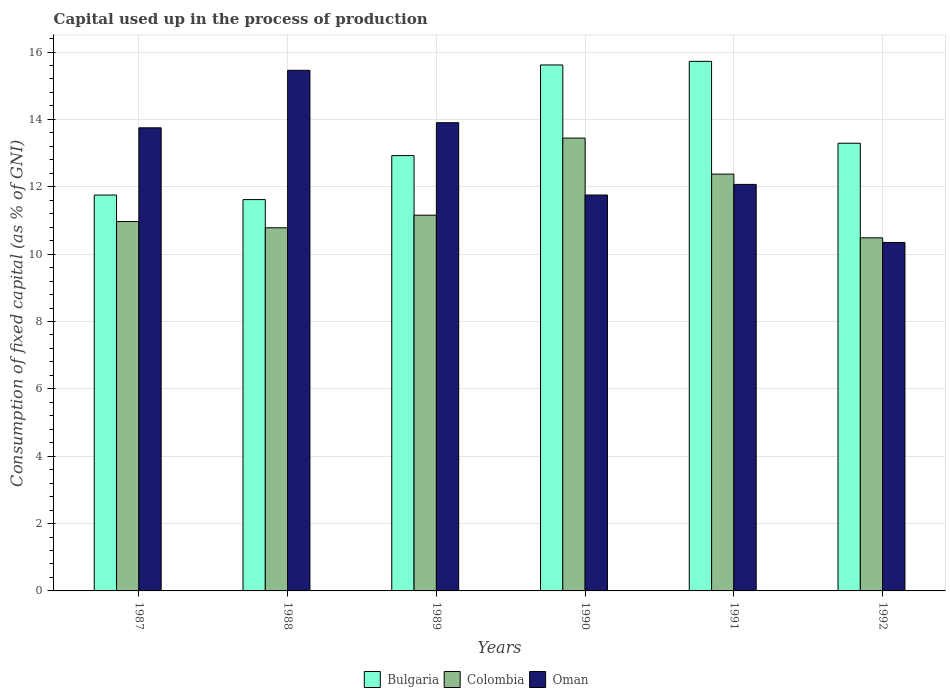How many groups of bars are there?
Ensure brevity in your answer.  6. Are the number of bars per tick equal to the number of legend labels?
Keep it short and to the point. Yes. How many bars are there on the 1st tick from the left?
Offer a terse response. 3. How many bars are there on the 4th tick from the right?
Provide a succinct answer. 3. What is the label of the 3rd group of bars from the left?
Ensure brevity in your answer.  1989. In how many cases, is the number of bars for a given year not equal to the number of legend labels?
Your answer should be compact. 0. What is the capital used up in the process of production in Oman in 1990?
Make the answer very short. 11.76. Across all years, what is the maximum capital used up in the process of production in Bulgaria?
Your answer should be very brief. 15.72. Across all years, what is the minimum capital used up in the process of production in Colombia?
Your answer should be compact. 10.48. In which year was the capital used up in the process of production in Oman minimum?
Provide a succinct answer. 1992. What is the total capital used up in the process of production in Colombia in the graph?
Make the answer very short. 69.21. What is the difference between the capital used up in the process of production in Bulgaria in 1988 and that in 1989?
Make the answer very short. -1.31. What is the difference between the capital used up in the process of production in Bulgaria in 1987 and the capital used up in the process of production in Colombia in 1991?
Ensure brevity in your answer.  -0.62. What is the average capital used up in the process of production in Oman per year?
Your answer should be very brief. 12.88. In the year 1990, what is the difference between the capital used up in the process of production in Colombia and capital used up in the process of production in Bulgaria?
Provide a succinct answer. -2.17. In how many years, is the capital used up in the process of production in Oman greater than 3.2 %?
Ensure brevity in your answer.  6. What is the ratio of the capital used up in the process of production in Oman in 1988 to that in 1990?
Your answer should be compact. 1.31. Is the capital used up in the process of production in Bulgaria in 1987 less than that in 1990?
Offer a terse response. Yes. Is the difference between the capital used up in the process of production in Colombia in 1988 and 1990 greater than the difference between the capital used up in the process of production in Bulgaria in 1988 and 1990?
Give a very brief answer. Yes. What is the difference between the highest and the second highest capital used up in the process of production in Bulgaria?
Offer a very short reply. 0.11. What is the difference between the highest and the lowest capital used up in the process of production in Bulgaria?
Provide a short and direct response. 4.1. In how many years, is the capital used up in the process of production in Bulgaria greater than the average capital used up in the process of production in Bulgaria taken over all years?
Provide a short and direct response. 2. Is the sum of the capital used up in the process of production in Colombia in 1987 and 1988 greater than the maximum capital used up in the process of production in Oman across all years?
Provide a short and direct response. Yes. What does the 1st bar from the right in 1991 represents?
Give a very brief answer. Oman. Are all the bars in the graph horizontal?
Ensure brevity in your answer.  No. How many years are there in the graph?
Your answer should be very brief. 6. What is the difference between two consecutive major ticks on the Y-axis?
Your answer should be very brief. 2. Are the values on the major ticks of Y-axis written in scientific E-notation?
Your response must be concise. No. Does the graph contain any zero values?
Offer a very short reply. No. Where does the legend appear in the graph?
Keep it short and to the point. Bottom center. How many legend labels are there?
Provide a succinct answer. 3. What is the title of the graph?
Your response must be concise. Capital used up in the process of production. What is the label or title of the X-axis?
Your answer should be very brief. Years. What is the label or title of the Y-axis?
Your answer should be compact. Consumption of fixed capital (as % of GNI). What is the Consumption of fixed capital (as % of GNI) of Bulgaria in 1987?
Provide a succinct answer. 11.75. What is the Consumption of fixed capital (as % of GNI) of Colombia in 1987?
Your answer should be very brief. 10.97. What is the Consumption of fixed capital (as % of GNI) in Oman in 1987?
Keep it short and to the point. 13.75. What is the Consumption of fixed capital (as % of GNI) of Bulgaria in 1988?
Give a very brief answer. 11.62. What is the Consumption of fixed capital (as % of GNI) of Colombia in 1988?
Give a very brief answer. 10.78. What is the Consumption of fixed capital (as % of GNI) in Oman in 1988?
Your answer should be very brief. 15.46. What is the Consumption of fixed capital (as % of GNI) of Bulgaria in 1989?
Provide a succinct answer. 12.93. What is the Consumption of fixed capital (as % of GNI) in Colombia in 1989?
Your answer should be compact. 11.16. What is the Consumption of fixed capital (as % of GNI) of Oman in 1989?
Keep it short and to the point. 13.9. What is the Consumption of fixed capital (as % of GNI) in Bulgaria in 1990?
Provide a succinct answer. 15.62. What is the Consumption of fixed capital (as % of GNI) in Colombia in 1990?
Ensure brevity in your answer.  13.45. What is the Consumption of fixed capital (as % of GNI) of Oman in 1990?
Your answer should be very brief. 11.76. What is the Consumption of fixed capital (as % of GNI) of Bulgaria in 1991?
Provide a succinct answer. 15.72. What is the Consumption of fixed capital (as % of GNI) in Colombia in 1991?
Your answer should be compact. 12.38. What is the Consumption of fixed capital (as % of GNI) of Oman in 1991?
Ensure brevity in your answer.  12.07. What is the Consumption of fixed capital (as % of GNI) in Bulgaria in 1992?
Offer a very short reply. 13.29. What is the Consumption of fixed capital (as % of GNI) in Colombia in 1992?
Your answer should be compact. 10.48. What is the Consumption of fixed capital (as % of GNI) of Oman in 1992?
Provide a succinct answer. 10.35. Across all years, what is the maximum Consumption of fixed capital (as % of GNI) of Bulgaria?
Offer a terse response. 15.72. Across all years, what is the maximum Consumption of fixed capital (as % of GNI) in Colombia?
Offer a terse response. 13.45. Across all years, what is the maximum Consumption of fixed capital (as % of GNI) in Oman?
Make the answer very short. 15.46. Across all years, what is the minimum Consumption of fixed capital (as % of GNI) in Bulgaria?
Give a very brief answer. 11.62. Across all years, what is the minimum Consumption of fixed capital (as % of GNI) of Colombia?
Provide a succinct answer. 10.48. Across all years, what is the minimum Consumption of fixed capital (as % of GNI) in Oman?
Your response must be concise. 10.35. What is the total Consumption of fixed capital (as % of GNI) of Bulgaria in the graph?
Your answer should be very brief. 80.93. What is the total Consumption of fixed capital (as % of GNI) of Colombia in the graph?
Keep it short and to the point. 69.21. What is the total Consumption of fixed capital (as % of GNI) in Oman in the graph?
Offer a very short reply. 77.28. What is the difference between the Consumption of fixed capital (as % of GNI) of Bulgaria in 1987 and that in 1988?
Ensure brevity in your answer.  0.14. What is the difference between the Consumption of fixed capital (as % of GNI) of Colombia in 1987 and that in 1988?
Offer a very short reply. 0.18. What is the difference between the Consumption of fixed capital (as % of GNI) in Oman in 1987 and that in 1988?
Your answer should be compact. -1.71. What is the difference between the Consumption of fixed capital (as % of GNI) in Bulgaria in 1987 and that in 1989?
Keep it short and to the point. -1.17. What is the difference between the Consumption of fixed capital (as % of GNI) in Colombia in 1987 and that in 1989?
Your answer should be very brief. -0.19. What is the difference between the Consumption of fixed capital (as % of GNI) in Oman in 1987 and that in 1989?
Your answer should be compact. -0.15. What is the difference between the Consumption of fixed capital (as % of GNI) in Bulgaria in 1987 and that in 1990?
Your answer should be compact. -3.86. What is the difference between the Consumption of fixed capital (as % of GNI) in Colombia in 1987 and that in 1990?
Make the answer very short. -2.48. What is the difference between the Consumption of fixed capital (as % of GNI) in Oman in 1987 and that in 1990?
Provide a succinct answer. 2. What is the difference between the Consumption of fixed capital (as % of GNI) in Bulgaria in 1987 and that in 1991?
Your response must be concise. -3.97. What is the difference between the Consumption of fixed capital (as % of GNI) of Colombia in 1987 and that in 1991?
Ensure brevity in your answer.  -1.41. What is the difference between the Consumption of fixed capital (as % of GNI) of Oman in 1987 and that in 1991?
Offer a very short reply. 1.68. What is the difference between the Consumption of fixed capital (as % of GNI) in Bulgaria in 1987 and that in 1992?
Your answer should be very brief. -1.54. What is the difference between the Consumption of fixed capital (as % of GNI) of Colombia in 1987 and that in 1992?
Provide a short and direct response. 0.48. What is the difference between the Consumption of fixed capital (as % of GNI) in Oman in 1987 and that in 1992?
Offer a very short reply. 3.4. What is the difference between the Consumption of fixed capital (as % of GNI) in Bulgaria in 1988 and that in 1989?
Ensure brevity in your answer.  -1.31. What is the difference between the Consumption of fixed capital (as % of GNI) in Colombia in 1988 and that in 1989?
Your response must be concise. -0.37. What is the difference between the Consumption of fixed capital (as % of GNI) in Oman in 1988 and that in 1989?
Your answer should be very brief. 1.56. What is the difference between the Consumption of fixed capital (as % of GNI) of Bulgaria in 1988 and that in 1990?
Give a very brief answer. -4. What is the difference between the Consumption of fixed capital (as % of GNI) of Colombia in 1988 and that in 1990?
Give a very brief answer. -2.66. What is the difference between the Consumption of fixed capital (as % of GNI) of Oman in 1988 and that in 1990?
Give a very brief answer. 3.7. What is the difference between the Consumption of fixed capital (as % of GNI) of Bulgaria in 1988 and that in 1991?
Provide a succinct answer. -4.1. What is the difference between the Consumption of fixed capital (as % of GNI) in Colombia in 1988 and that in 1991?
Offer a very short reply. -1.59. What is the difference between the Consumption of fixed capital (as % of GNI) in Oman in 1988 and that in 1991?
Offer a very short reply. 3.39. What is the difference between the Consumption of fixed capital (as % of GNI) in Bulgaria in 1988 and that in 1992?
Provide a succinct answer. -1.67. What is the difference between the Consumption of fixed capital (as % of GNI) in Colombia in 1988 and that in 1992?
Offer a terse response. 0.3. What is the difference between the Consumption of fixed capital (as % of GNI) of Oman in 1988 and that in 1992?
Provide a short and direct response. 5.11. What is the difference between the Consumption of fixed capital (as % of GNI) in Bulgaria in 1989 and that in 1990?
Make the answer very short. -2.69. What is the difference between the Consumption of fixed capital (as % of GNI) of Colombia in 1989 and that in 1990?
Offer a terse response. -2.29. What is the difference between the Consumption of fixed capital (as % of GNI) in Oman in 1989 and that in 1990?
Give a very brief answer. 2.15. What is the difference between the Consumption of fixed capital (as % of GNI) in Bulgaria in 1989 and that in 1991?
Your response must be concise. -2.8. What is the difference between the Consumption of fixed capital (as % of GNI) of Colombia in 1989 and that in 1991?
Offer a very short reply. -1.22. What is the difference between the Consumption of fixed capital (as % of GNI) of Oman in 1989 and that in 1991?
Provide a succinct answer. 1.83. What is the difference between the Consumption of fixed capital (as % of GNI) in Bulgaria in 1989 and that in 1992?
Your answer should be very brief. -0.37. What is the difference between the Consumption of fixed capital (as % of GNI) in Colombia in 1989 and that in 1992?
Keep it short and to the point. 0.67. What is the difference between the Consumption of fixed capital (as % of GNI) in Oman in 1989 and that in 1992?
Offer a very short reply. 3.56. What is the difference between the Consumption of fixed capital (as % of GNI) of Bulgaria in 1990 and that in 1991?
Provide a succinct answer. -0.11. What is the difference between the Consumption of fixed capital (as % of GNI) in Colombia in 1990 and that in 1991?
Give a very brief answer. 1.07. What is the difference between the Consumption of fixed capital (as % of GNI) in Oman in 1990 and that in 1991?
Offer a terse response. -0.31. What is the difference between the Consumption of fixed capital (as % of GNI) in Bulgaria in 1990 and that in 1992?
Your answer should be very brief. 2.32. What is the difference between the Consumption of fixed capital (as % of GNI) of Colombia in 1990 and that in 1992?
Ensure brevity in your answer.  2.96. What is the difference between the Consumption of fixed capital (as % of GNI) of Oman in 1990 and that in 1992?
Give a very brief answer. 1.41. What is the difference between the Consumption of fixed capital (as % of GNI) of Bulgaria in 1991 and that in 1992?
Make the answer very short. 2.43. What is the difference between the Consumption of fixed capital (as % of GNI) of Colombia in 1991 and that in 1992?
Your answer should be very brief. 1.89. What is the difference between the Consumption of fixed capital (as % of GNI) of Oman in 1991 and that in 1992?
Offer a very short reply. 1.72. What is the difference between the Consumption of fixed capital (as % of GNI) in Bulgaria in 1987 and the Consumption of fixed capital (as % of GNI) in Colombia in 1988?
Your answer should be compact. 0.97. What is the difference between the Consumption of fixed capital (as % of GNI) of Bulgaria in 1987 and the Consumption of fixed capital (as % of GNI) of Oman in 1988?
Provide a short and direct response. -3.7. What is the difference between the Consumption of fixed capital (as % of GNI) of Colombia in 1987 and the Consumption of fixed capital (as % of GNI) of Oman in 1988?
Offer a terse response. -4.49. What is the difference between the Consumption of fixed capital (as % of GNI) in Bulgaria in 1987 and the Consumption of fixed capital (as % of GNI) in Colombia in 1989?
Provide a short and direct response. 0.6. What is the difference between the Consumption of fixed capital (as % of GNI) in Bulgaria in 1987 and the Consumption of fixed capital (as % of GNI) in Oman in 1989?
Give a very brief answer. -2.15. What is the difference between the Consumption of fixed capital (as % of GNI) in Colombia in 1987 and the Consumption of fixed capital (as % of GNI) in Oman in 1989?
Provide a short and direct response. -2.94. What is the difference between the Consumption of fixed capital (as % of GNI) of Bulgaria in 1987 and the Consumption of fixed capital (as % of GNI) of Colombia in 1990?
Ensure brevity in your answer.  -1.69. What is the difference between the Consumption of fixed capital (as % of GNI) of Bulgaria in 1987 and the Consumption of fixed capital (as % of GNI) of Oman in 1990?
Keep it short and to the point. -0. What is the difference between the Consumption of fixed capital (as % of GNI) in Colombia in 1987 and the Consumption of fixed capital (as % of GNI) in Oman in 1990?
Keep it short and to the point. -0.79. What is the difference between the Consumption of fixed capital (as % of GNI) of Bulgaria in 1987 and the Consumption of fixed capital (as % of GNI) of Colombia in 1991?
Offer a very short reply. -0.62. What is the difference between the Consumption of fixed capital (as % of GNI) in Bulgaria in 1987 and the Consumption of fixed capital (as % of GNI) in Oman in 1991?
Keep it short and to the point. -0.32. What is the difference between the Consumption of fixed capital (as % of GNI) of Colombia in 1987 and the Consumption of fixed capital (as % of GNI) of Oman in 1991?
Offer a terse response. -1.1. What is the difference between the Consumption of fixed capital (as % of GNI) of Bulgaria in 1987 and the Consumption of fixed capital (as % of GNI) of Colombia in 1992?
Your answer should be very brief. 1.27. What is the difference between the Consumption of fixed capital (as % of GNI) in Bulgaria in 1987 and the Consumption of fixed capital (as % of GNI) in Oman in 1992?
Offer a terse response. 1.41. What is the difference between the Consumption of fixed capital (as % of GNI) of Colombia in 1987 and the Consumption of fixed capital (as % of GNI) of Oman in 1992?
Your answer should be very brief. 0.62. What is the difference between the Consumption of fixed capital (as % of GNI) in Bulgaria in 1988 and the Consumption of fixed capital (as % of GNI) in Colombia in 1989?
Provide a succinct answer. 0.46. What is the difference between the Consumption of fixed capital (as % of GNI) of Bulgaria in 1988 and the Consumption of fixed capital (as % of GNI) of Oman in 1989?
Your response must be concise. -2.28. What is the difference between the Consumption of fixed capital (as % of GNI) in Colombia in 1988 and the Consumption of fixed capital (as % of GNI) in Oman in 1989?
Provide a succinct answer. -3.12. What is the difference between the Consumption of fixed capital (as % of GNI) in Bulgaria in 1988 and the Consumption of fixed capital (as % of GNI) in Colombia in 1990?
Provide a short and direct response. -1.83. What is the difference between the Consumption of fixed capital (as % of GNI) of Bulgaria in 1988 and the Consumption of fixed capital (as % of GNI) of Oman in 1990?
Offer a terse response. -0.14. What is the difference between the Consumption of fixed capital (as % of GNI) in Colombia in 1988 and the Consumption of fixed capital (as % of GNI) in Oman in 1990?
Offer a terse response. -0.97. What is the difference between the Consumption of fixed capital (as % of GNI) in Bulgaria in 1988 and the Consumption of fixed capital (as % of GNI) in Colombia in 1991?
Keep it short and to the point. -0.76. What is the difference between the Consumption of fixed capital (as % of GNI) of Bulgaria in 1988 and the Consumption of fixed capital (as % of GNI) of Oman in 1991?
Make the answer very short. -0.45. What is the difference between the Consumption of fixed capital (as % of GNI) of Colombia in 1988 and the Consumption of fixed capital (as % of GNI) of Oman in 1991?
Offer a terse response. -1.29. What is the difference between the Consumption of fixed capital (as % of GNI) in Bulgaria in 1988 and the Consumption of fixed capital (as % of GNI) in Colombia in 1992?
Your answer should be very brief. 1.14. What is the difference between the Consumption of fixed capital (as % of GNI) in Bulgaria in 1988 and the Consumption of fixed capital (as % of GNI) in Oman in 1992?
Offer a terse response. 1.27. What is the difference between the Consumption of fixed capital (as % of GNI) of Colombia in 1988 and the Consumption of fixed capital (as % of GNI) of Oman in 1992?
Your answer should be compact. 0.44. What is the difference between the Consumption of fixed capital (as % of GNI) in Bulgaria in 1989 and the Consumption of fixed capital (as % of GNI) in Colombia in 1990?
Ensure brevity in your answer.  -0.52. What is the difference between the Consumption of fixed capital (as % of GNI) in Bulgaria in 1989 and the Consumption of fixed capital (as % of GNI) in Oman in 1990?
Your answer should be compact. 1.17. What is the difference between the Consumption of fixed capital (as % of GNI) in Colombia in 1989 and the Consumption of fixed capital (as % of GNI) in Oman in 1990?
Provide a short and direct response. -0.6. What is the difference between the Consumption of fixed capital (as % of GNI) in Bulgaria in 1989 and the Consumption of fixed capital (as % of GNI) in Colombia in 1991?
Provide a short and direct response. 0.55. What is the difference between the Consumption of fixed capital (as % of GNI) of Bulgaria in 1989 and the Consumption of fixed capital (as % of GNI) of Oman in 1991?
Your response must be concise. 0.86. What is the difference between the Consumption of fixed capital (as % of GNI) of Colombia in 1989 and the Consumption of fixed capital (as % of GNI) of Oman in 1991?
Your answer should be very brief. -0.91. What is the difference between the Consumption of fixed capital (as % of GNI) in Bulgaria in 1989 and the Consumption of fixed capital (as % of GNI) in Colombia in 1992?
Your answer should be compact. 2.44. What is the difference between the Consumption of fixed capital (as % of GNI) in Bulgaria in 1989 and the Consumption of fixed capital (as % of GNI) in Oman in 1992?
Your response must be concise. 2.58. What is the difference between the Consumption of fixed capital (as % of GNI) of Colombia in 1989 and the Consumption of fixed capital (as % of GNI) of Oman in 1992?
Provide a short and direct response. 0.81. What is the difference between the Consumption of fixed capital (as % of GNI) of Bulgaria in 1990 and the Consumption of fixed capital (as % of GNI) of Colombia in 1991?
Provide a short and direct response. 3.24. What is the difference between the Consumption of fixed capital (as % of GNI) of Bulgaria in 1990 and the Consumption of fixed capital (as % of GNI) of Oman in 1991?
Offer a very short reply. 3.55. What is the difference between the Consumption of fixed capital (as % of GNI) in Colombia in 1990 and the Consumption of fixed capital (as % of GNI) in Oman in 1991?
Your answer should be compact. 1.38. What is the difference between the Consumption of fixed capital (as % of GNI) in Bulgaria in 1990 and the Consumption of fixed capital (as % of GNI) in Colombia in 1992?
Ensure brevity in your answer.  5.13. What is the difference between the Consumption of fixed capital (as % of GNI) in Bulgaria in 1990 and the Consumption of fixed capital (as % of GNI) in Oman in 1992?
Your answer should be compact. 5.27. What is the difference between the Consumption of fixed capital (as % of GNI) of Colombia in 1990 and the Consumption of fixed capital (as % of GNI) of Oman in 1992?
Provide a short and direct response. 3.1. What is the difference between the Consumption of fixed capital (as % of GNI) of Bulgaria in 1991 and the Consumption of fixed capital (as % of GNI) of Colombia in 1992?
Make the answer very short. 5.24. What is the difference between the Consumption of fixed capital (as % of GNI) in Bulgaria in 1991 and the Consumption of fixed capital (as % of GNI) in Oman in 1992?
Offer a terse response. 5.38. What is the difference between the Consumption of fixed capital (as % of GNI) in Colombia in 1991 and the Consumption of fixed capital (as % of GNI) in Oman in 1992?
Keep it short and to the point. 2.03. What is the average Consumption of fixed capital (as % of GNI) in Bulgaria per year?
Ensure brevity in your answer.  13.49. What is the average Consumption of fixed capital (as % of GNI) in Colombia per year?
Offer a terse response. 11.54. What is the average Consumption of fixed capital (as % of GNI) in Oman per year?
Your answer should be compact. 12.88. In the year 1987, what is the difference between the Consumption of fixed capital (as % of GNI) in Bulgaria and Consumption of fixed capital (as % of GNI) in Colombia?
Give a very brief answer. 0.79. In the year 1987, what is the difference between the Consumption of fixed capital (as % of GNI) of Bulgaria and Consumption of fixed capital (as % of GNI) of Oman?
Offer a terse response. -2. In the year 1987, what is the difference between the Consumption of fixed capital (as % of GNI) in Colombia and Consumption of fixed capital (as % of GNI) in Oman?
Your answer should be compact. -2.78. In the year 1988, what is the difference between the Consumption of fixed capital (as % of GNI) in Bulgaria and Consumption of fixed capital (as % of GNI) in Colombia?
Provide a succinct answer. 0.84. In the year 1988, what is the difference between the Consumption of fixed capital (as % of GNI) of Bulgaria and Consumption of fixed capital (as % of GNI) of Oman?
Make the answer very short. -3.84. In the year 1988, what is the difference between the Consumption of fixed capital (as % of GNI) in Colombia and Consumption of fixed capital (as % of GNI) in Oman?
Provide a short and direct response. -4.68. In the year 1989, what is the difference between the Consumption of fixed capital (as % of GNI) in Bulgaria and Consumption of fixed capital (as % of GNI) in Colombia?
Provide a short and direct response. 1.77. In the year 1989, what is the difference between the Consumption of fixed capital (as % of GNI) of Bulgaria and Consumption of fixed capital (as % of GNI) of Oman?
Offer a terse response. -0.98. In the year 1989, what is the difference between the Consumption of fixed capital (as % of GNI) in Colombia and Consumption of fixed capital (as % of GNI) in Oman?
Your answer should be compact. -2.75. In the year 1990, what is the difference between the Consumption of fixed capital (as % of GNI) of Bulgaria and Consumption of fixed capital (as % of GNI) of Colombia?
Your answer should be compact. 2.17. In the year 1990, what is the difference between the Consumption of fixed capital (as % of GNI) in Bulgaria and Consumption of fixed capital (as % of GNI) in Oman?
Your response must be concise. 3.86. In the year 1990, what is the difference between the Consumption of fixed capital (as % of GNI) in Colombia and Consumption of fixed capital (as % of GNI) in Oman?
Your response must be concise. 1.69. In the year 1991, what is the difference between the Consumption of fixed capital (as % of GNI) of Bulgaria and Consumption of fixed capital (as % of GNI) of Colombia?
Offer a terse response. 3.35. In the year 1991, what is the difference between the Consumption of fixed capital (as % of GNI) in Bulgaria and Consumption of fixed capital (as % of GNI) in Oman?
Your answer should be very brief. 3.65. In the year 1991, what is the difference between the Consumption of fixed capital (as % of GNI) in Colombia and Consumption of fixed capital (as % of GNI) in Oman?
Provide a succinct answer. 0.31. In the year 1992, what is the difference between the Consumption of fixed capital (as % of GNI) of Bulgaria and Consumption of fixed capital (as % of GNI) of Colombia?
Offer a terse response. 2.81. In the year 1992, what is the difference between the Consumption of fixed capital (as % of GNI) in Bulgaria and Consumption of fixed capital (as % of GNI) in Oman?
Ensure brevity in your answer.  2.95. In the year 1992, what is the difference between the Consumption of fixed capital (as % of GNI) of Colombia and Consumption of fixed capital (as % of GNI) of Oman?
Give a very brief answer. 0.14. What is the ratio of the Consumption of fixed capital (as % of GNI) of Bulgaria in 1987 to that in 1988?
Make the answer very short. 1.01. What is the ratio of the Consumption of fixed capital (as % of GNI) in Colombia in 1987 to that in 1988?
Give a very brief answer. 1.02. What is the ratio of the Consumption of fixed capital (as % of GNI) in Oman in 1987 to that in 1988?
Make the answer very short. 0.89. What is the ratio of the Consumption of fixed capital (as % of GNI) in Bulgaria in 1987 to that in 1989?
Make the answer very short. 0.91. What is the ratio of the Consumption of fixed capital (as % of GNI) of Colombia in 1987 to that in 1989?
Keep it short and to the point. 0.98. What is the ratio of the Consumption of fixed capital (as % of GNI) in Oman in 1987 to that in 1989?
Your response must be concise. 0.99. What is the ratio of the Consumption of fixed capital (as % of GNI) in Bulgaria in 1987 to that in 1990?
Your answer should be compact. 0.75. What is the ratio of the Consumption of fixed capital (as % of GNI) of Colombia in 1987 to that in 1990?
Offer a very short reply. 0.82. What is the ratio of the Consumption of fixed capital (as % of GNI) of Oman in 1987 to that in 1990?
Offer a very short reply. 1.17. What is the ratio of the Consumption of fixed capital (as % of GNI) in Bulgaria in 1987 to that in 1991?
Offer a very short reply. 0.75. What is the ratio of the Consumption of fixed capital (as % of GNI) of Colombia in 1987 to that in 1991?
Offer a terse response. 0.89. What is the ratio of the Consumption of fixed capital (as % of GNI) in Oman in 1987 to that in 1991?
Your answer should be very brief. 1.14. What is the ratio of the Consumption of fixed capital (as % of GNI) in Bulgaria in 1987 to that in 1992?
Make the answer very short. 0.88. What is the ratio of the Consumption of fixed capital (as % of GNI) in Colombia in 1987 to that in 1992?
Ensure brevity in your answer.  1.05. What is the ratio of the Consumption of fixed capital (as % of GNI) in Oman in 1987 to that in 1992?
Provide a short and direct response. 1.33. What is the ratio of the Consumption of fixed capital (as % of GNI) in Bulgaria in 1988 to that in 1989?
Provide a short and direct response. 0.9. What is the ratio of the Consumption of fixed capital (as % of GNI) of Colombia in 1988 to that in 1989?
Your response must be concise. 0.97. What is the ratio of the Consumption of fixed capital (as % of GNI) in Oman in 1988 to that in 1989?
Your answer should be compact. 1.11. What is the ratio of the Consumption of fixed capital (as % of GNI) in Bulgaria in 1988 to that in 1990?
Make the answer very short. 0.74. What is the ratio of the Consumption of fixed capital (as % of GNI) in Colombia in 1988 to that in 1990?
Give a very brief answer. 0.8. What is the ratio of the Consumption of fixed capital (as % of GNI) in Oman in 1988 to that in 1990?
Your answer should be compact. 1.31. What is the ratio of the Consumption of fixed capital (as % of GNI) in Bulgaria in 1988 to that in 1991?
Make the answer very short. 0.74. What is the ratio of the Consumption of fixed capital (as % of GNI) of Colombia in 1988 to that in 1991?
Ensure brevity in your answer.  0.87. What is the ratio of the Consumption of fixed capital (as % of GNI) of Oman in 1988 to that in 1991?
Offer a terse response. 1.28. What is the ratio of the Consumption of fixed capital (as % of GNI) in Bulgaria in 1988 to that in 1992?
Provide a succinct answer. 0.87. What is the ratio of the Consumption of fixed capital (as % of GNI) of Colombia in 1988 to that in 1992?
Your answer should be compact. 1.03. What is the ratio of the Consumption of fixed capital (as % of GNI) in Oman in 1988 to that in 1992?
Your answer should be very brief. 1.49. What is the ratio of the Consumption of fixed capital (as % of GNI) in Bulgaria in 1989 to that in 1990?
Provide a succinct answer. 0.83. What is the ratio of the Consumption of fixed capital (as % of GNI) of Colombia in 1989 to that in 1990?
Keep it short and to the point. 0.83. What is the ratio of the Consumption of fixed capital (as % of GNI) in Oman in 1989 to that in 1990?
Your response must be concise. 1.18. What is the ratio of the Consumption of fixed capital (as % of GNI) of Bulgaria in 1989 to that in 1991?
Offer a terse response. 0.82. What is the ratio of the Consumption of fixed capital (as % of GNI) in Colombia in 1989 to that in 1991?
Your answer should be very brief. 0.9. What is the ratio of the Consumption of fixed capital (as % of GNI) of Oman in 1989 to that in 1991?
Give a very brief answer. 1.15. What is the ratio of the Consumption of fixed capital (as % of GNI) of Bulgaria in 1989 to that in 1992?
Ensure brevity in your answer.  0.97. What is the ratio of the Consumption of fixed capital (as % of GNI) in Colombia in 1989 to that in 1992?
Give a very brief answer. 1.06. What is the ratio of the Consumption of fixed capital (as % of GNI) of Oman in 1989 to that in 1992?
Your answer should be compact. 1.34. What is the ratio of the Consumption of fixed capital (as % of GNI) in Colombia in 1990 to that in 1991?
Give a very brief answer. 1.09. What is the ratio of the Consumption of fixed capital (as % of GNI) in Oman in 1990 to that in 1991?
Keep it short and to the point. 0.97. What is the ratio of the Consumption of fixed capital (as % of GNI) of Bulgaria in 1990 to that in 1992?
Offer a very short reply. 1.17. What is the ratio of the Consumption of fixed capital (as % of GNI) of Colombia in 1990 to that in 1992?
Your response must be concise. 1.28. What is the ratio of the Consumption of fixed capital (as % of GNI) in Oman in 1990 to that in 1992?
Your answer should be compact. 1.14. What is the ratio of the Consumption of fixed capital (as % of GNI) of Bulgaria in 1991 to that in 1992?
Provide a short and direct response. 1.18. What is the ratio of the Consumption of fixed capital (as % of GNI) of Colombia in 1991 to that in 1992?
Ensure brevity in your answer.  1.18. What is the ratio of the Consumption of fixed capital (as % of GNI) in Oman in 1991 to that in 1992?
Provide a short and direct response. 1.17. What is the difference between the highest and the second highest Consumption of fixed capital (as % of GNI) in Bulgaria?
Provide a short and direct response. 0.11. What is the difference between the highest and the second highest Consumption of fixed capital (as % of GNI) in Colombia?
Offer a terse response. 1.07. What is the difference between the highest and the second highest Consumption of fixed capital (as % of GNI) of Oman?
Your answer should be very brief. 1.56. What is the difference between the highest and the lowest Consumption of fixed capital (as % of GNI) of Bulgaria?
Ensure brevity in your answer.  4.1. What is the difference between the highest and the lowest Consumption of fixed capital (as % of GNI) in Colombia?
Your response must be concise. 2.96. What is the difference between the highest and the lowest Consumption of fixed capital (as % of GNI) in Oman?
Ensure brevity in your answer.  5.11. 